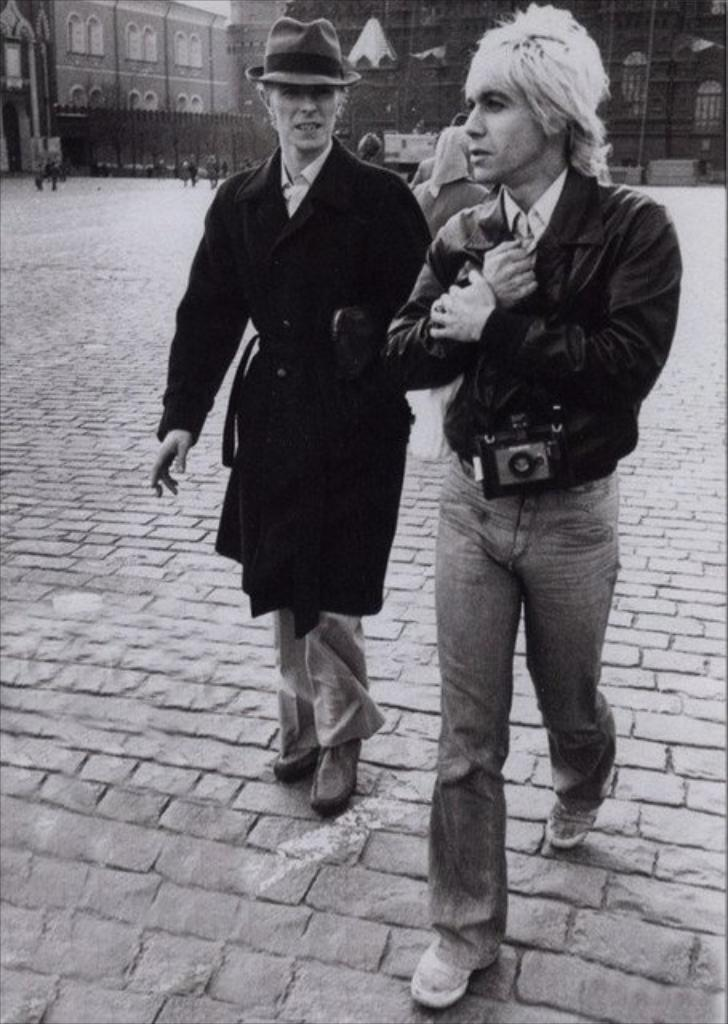What type of structures can be seen in the image? There are buildings in the image. Are there any living beings present in the image? Yes, there are people in the image. Can you describe the actions of any of the people in the image? One person is carrying an object in the image. How many rabbits can be seen in the image? There are no rabbits present in the image. What part of the brain is visible in the image? There is no brain present in the image. 